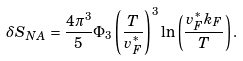Convert formula to latex. <formula><loc_0><loc_0><loc_500><loc_500>\delta S _ { N A } = \frac { 4 \pi ^ { 3 } } { 5 } \Phi _ { 3 } \left ( \frac { T } { v _ { F } ^ { \ast } } \right ) ^ { 3 } \ln \left ( \frac { v _ { F } ^ { \ast } k _ { F } } { T } \right ) .</formula> 